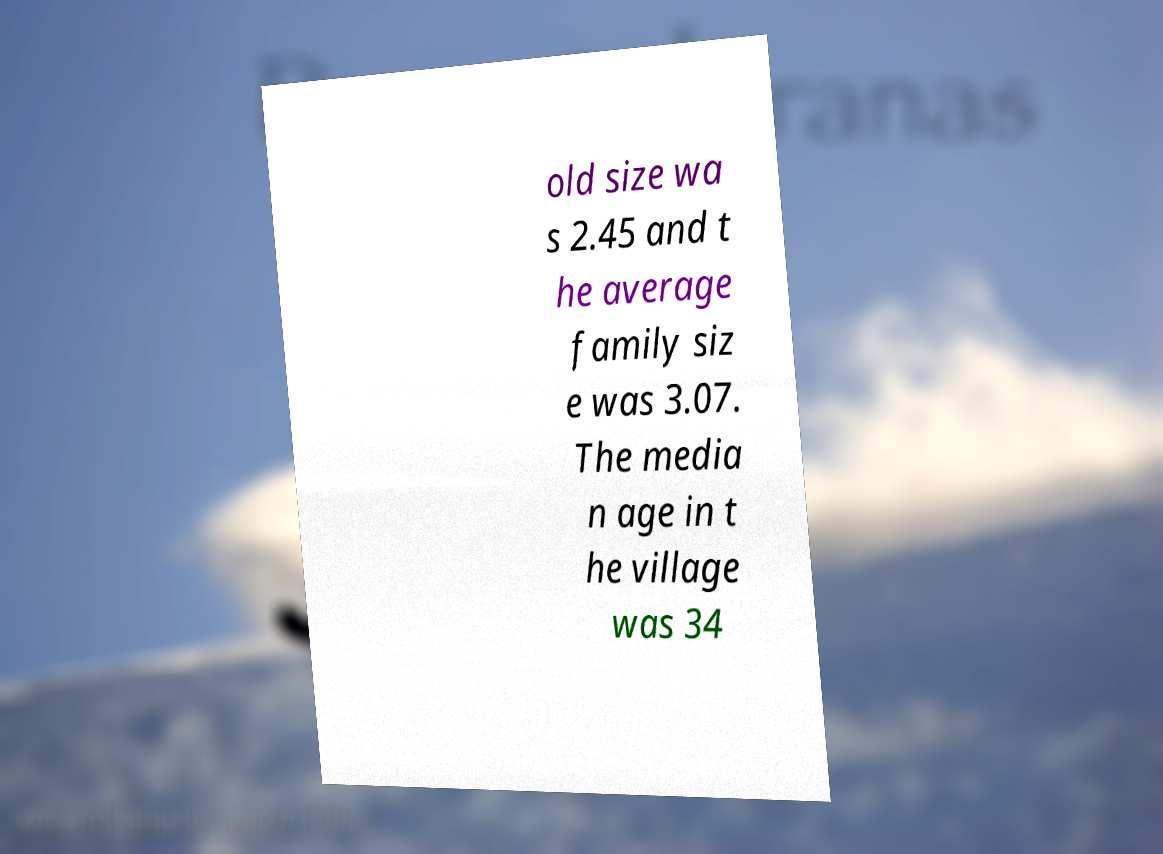Can you read and provide the text displayed in the image?This photo seems to have some interesting text. Can you extract and type it out for me? old size wa s 2.45 and t he average family siz e was 3.07. The media n age in t he village was 34 